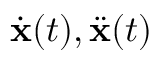<formula> <loc_0><loc_0><loc_500><loc_500>\dot { \mathbf x } ( t ) , \ddot { \mathbf x } ( t )</formula> 